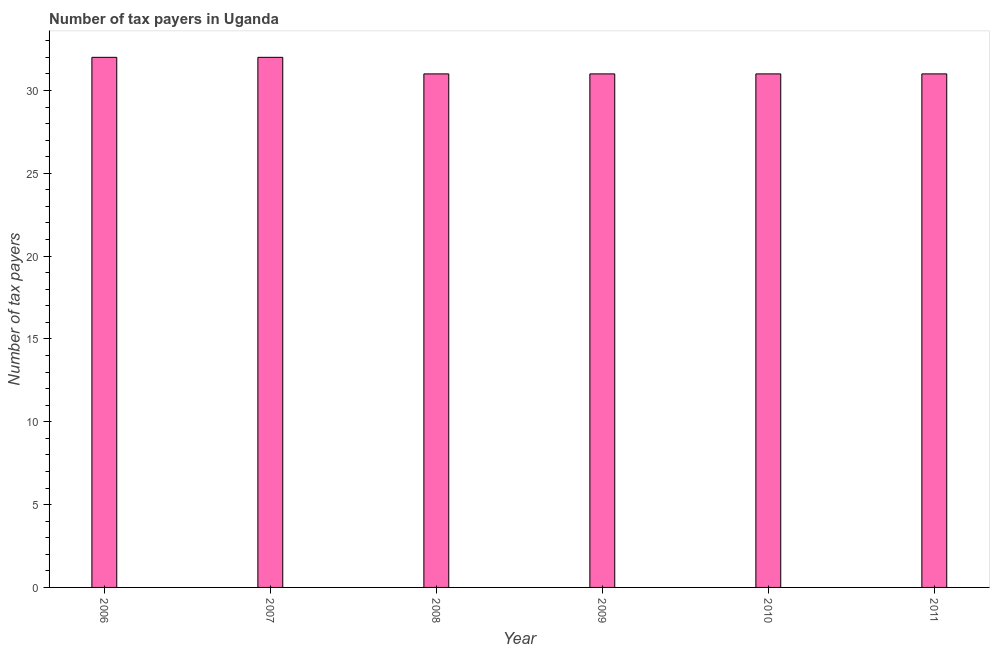Does the graph contain any zero values?
Your response must be concise. No. Does the graph contain grids?
Provide a short and direct response. No. What is the title of the graph?
Provide a succinct answer. Number of tax payers in Uganda. What is the label or title of the Y-axis?
Provide a short and direct response. Number of tax payers. Across all years, what is the minimum number of tax payers?
Your answer should be compact. 31. In which year was the number of tax payers maximum?
Your response must be concise. 2006. What is the sum of the number of tax payers?
Provide a succinct answer. 188. What is the difference between the number of tax payers in 2006 and 2009?
Keep it short and to the point. 1. What is the average number of tax payers per year?
Your answer should be very brief. 31. What is the median number of tax payers?
Provide a succinct answer. 31. Do a majority of the years between 2008 and 2007 (inclusive) have number of tax payers greater than 14 ?
Offer a very short reply. No. What is the ratio of the number of tax payers in 2009 to that in 2010?
Make the answer very short. 1. Is the number of tax payers in 2007 less than that in 2008?
Give a very brief answer. No. Is the difference between the number of tax payers in 2007 and 2010 greater than the difference between any two years?
Your response must be concise. Yes. What is the difference between the highest and the second highest number of tax payers?
Provide a short and direct response. 0. What is the difference between the highest and the lowest number of tax payers?
Keep it short and to the point. 1. In how many years, is the number of tax payers greater than the average number of tax payers taken over all years?
Give a very brief answer. 2. How many years are there in the graph?
Your answer should be compact. 6. Are the values on the major ticks of Y-axis written in scientific E-notation?
Provide a succinct answer. No. What is the Number of tax payers in 2008?
Make the answer very short. 31. What is the Number of tax payers in 2011?
Your response must be concise. 31. What is the difference between the Number of tax payers in 2006 and 2007?
Make the answer very short. 0. What is the difference between the Number of tax payers in 2006 and 2008?
Offer a very short reply. 1. What is the difference between the Number of tax payers in 2006 and 2009?
Make the answer very short. 1. What is the difference between the Number of tax payers in 2008 and 2011?
Offer a terse response. 0. What is the difference between the Number of tax payers in 2009 and 2011?
Keep it short and to the point. 0. What is the ratio of the Number of tax payers in 2006 to that in 2008?
Offer a very short reply. 1.03. What is the ratio of the Number of tax payers in 2006 to that in 2009?
Provide a short and direct response. 1.03. What is the ratio of the Number of tax payers in 2006 to that in 2010?
Offer a very short reply. 1.03. What is the ratio of the Number of tax payers in 2006 to that in 2011?
Provide a succinct answer. 1.03. What is the ratio of the Number of tax payers in 2007 to that in 2008?
Ensure brevity in your answer.  1.03. What is the ratio of the Number of tax payers in 2007 to that in 2009?
Give a very brief answer. 1.03. What is the ratio of the Number of tax payers in 2007 to that in 2010?
Ensure brevity in your answer.  1.03. What is the ratio of the Number of tax payers in 2007 to that in 2011?
Offer a very short reply. 1.03. What is the ratio of the Number of tax payers in 2009 to that in 2010?
Provide a short and direct response. 1. 